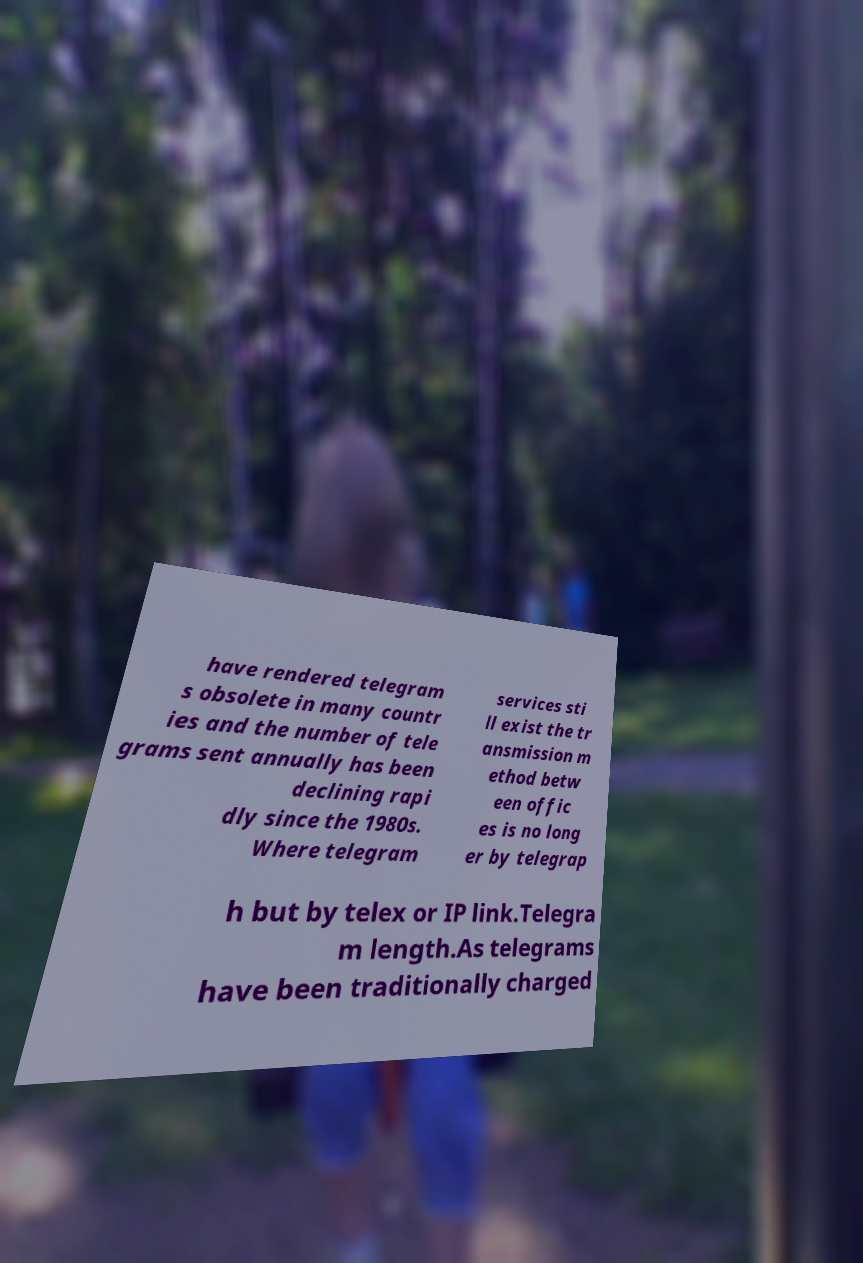For documentation purposes, I need the text within this image transcribed. Could you provide that? have rendered telegram s obsolete in many countr ies and the number of tele grams sent annually has been declining rapi dly since the 1980s. Where telegram services sti ll exist the tr ansmission m ethod betw een offic es is no long er by telegrap h but by telex or IP link.Telegra m length.As telegrams have been traditionally charged 